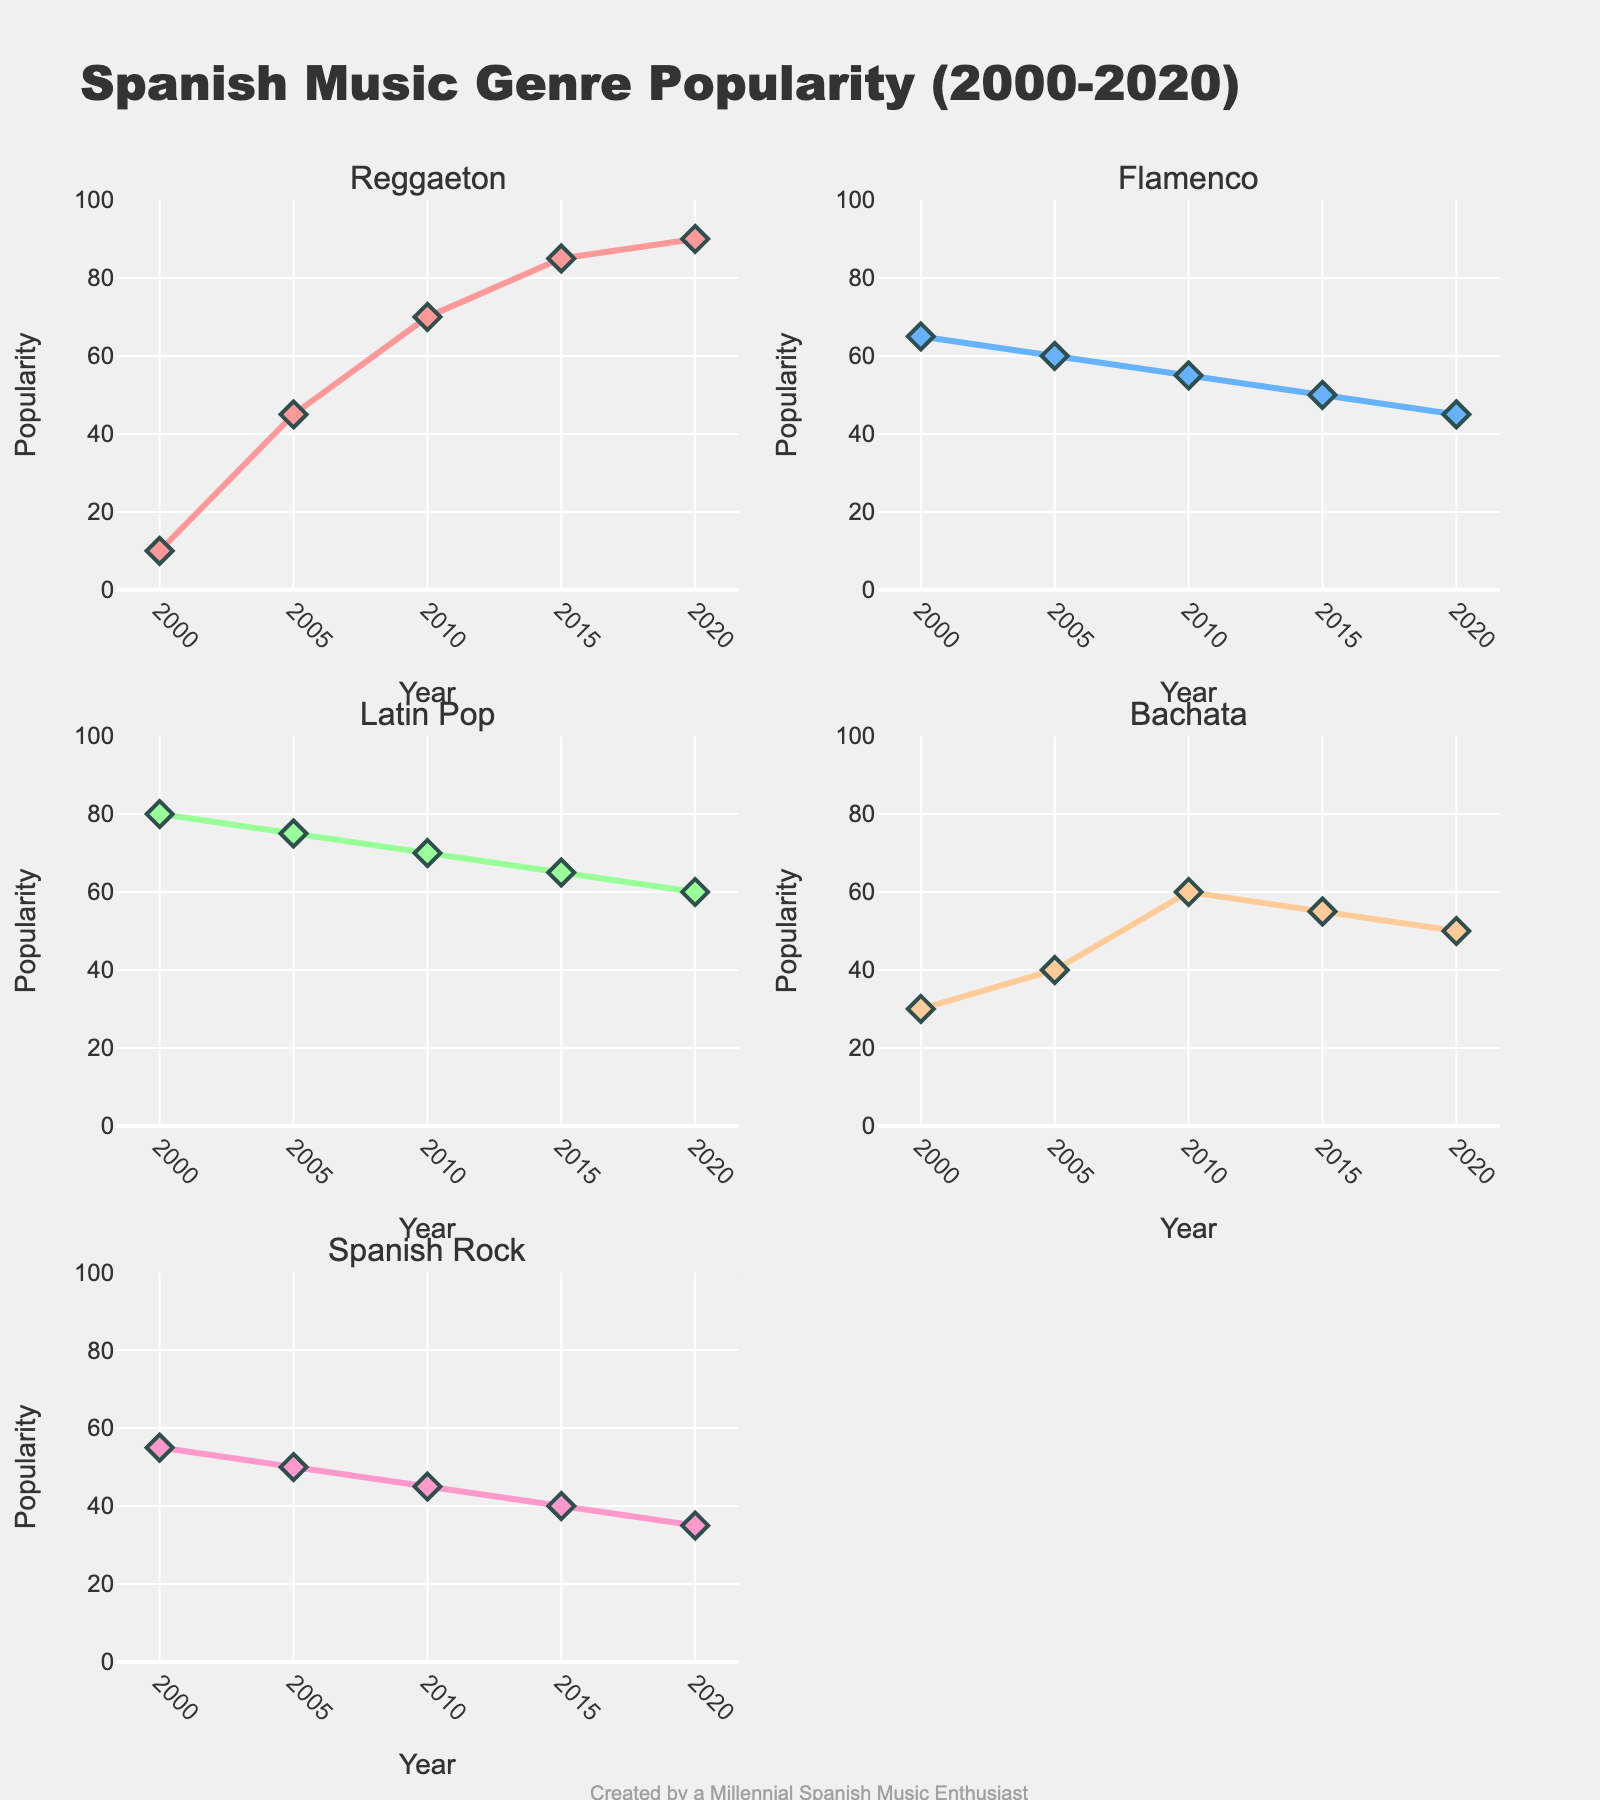What's the title of the figure? The title of the figure is displayed at the top of the plot. It reads "Spanish Music Genre Popularity (2000-2020)"
Answer: Spanish Music Genre Popularity (2000-2020) What are the genres represented in the plots? There are subplots for each genre, and their titles are shown above each subplot. The genres are Reggaeton, Flamenco, Latin Pop, Bachata, and Spanish Rock
Answer: Reggaeton, Flamenco, Latin Pop, Bachata, Spanish Rock How does the popularity of Reggaeton change from 2000 to 2020? To find this, look at the subplot for Reggaeton, noting the value for each year. In 2000, the popularity is 10, rising to 45 in 2005, 70 in 2010, 85 in 2015, and reaching 90 in 2020
Answer: It increases from 10 to 90 Which genre had the highest popularity in 2000, and what was the value? In 2000, by comparing the values in each of the subplots, Latin Pop has the highest popularity with a value of 80
Answer: Latin Pop, 80 Which genre shows a continuous decline in popularity over the years? Review each subplot to check for a continuous downward trend from 2000 to 2020. Flamenco has declining values: 65 (2000), 60 (2005), 55 (2010), 50 (2015), and 45 (2020)
Answer: Flamenco Between which years did Bachata see the largest increase in popularity? Look at the Bachata subplot and calculate the differences between consecutive years: 2005-2000 (10), 2010-2005 (20), 2015-2010 (-5), 2020-2015 (-5). The largest increase is between 2010 and 2005, with an increase of 20
Answer: 2005-2010 What's the average popularity of Spanish Rock over the given years? The values of Spanish Rock in each year are: 55, 50, 45, 40, and 35. Sum these values (55 + 50 + 45 + 40 + 35) which equals 225. Divide by the number of data points (5) to get the average, which is 225/5
Answer: 45 Which genre had the smallest difference in popularity between 2000 and 2020? Calculate the differences for each genre. Reggaeton: 90 - 10 = 80, Flamenco: 45 - 65 = -20, Latin Pop: 60 - 80 = -20, Bachata: 50 - 30 = 20, Spanish Rock: 35 - 55 = -20. Flamenco, Latin Pop, and Spanish Rock all show a difference of -20
Answer: Flamenco, Latin Pop, Spanish Rock Which genre maintained a steady popularity without extreme peaks or drops? Looking at the subplots for each genre, Latin Pop shows a relatively steady trend: 80, 75, 70, 65, 60, without extreme peaks or drops
Answer: Latin Pop 